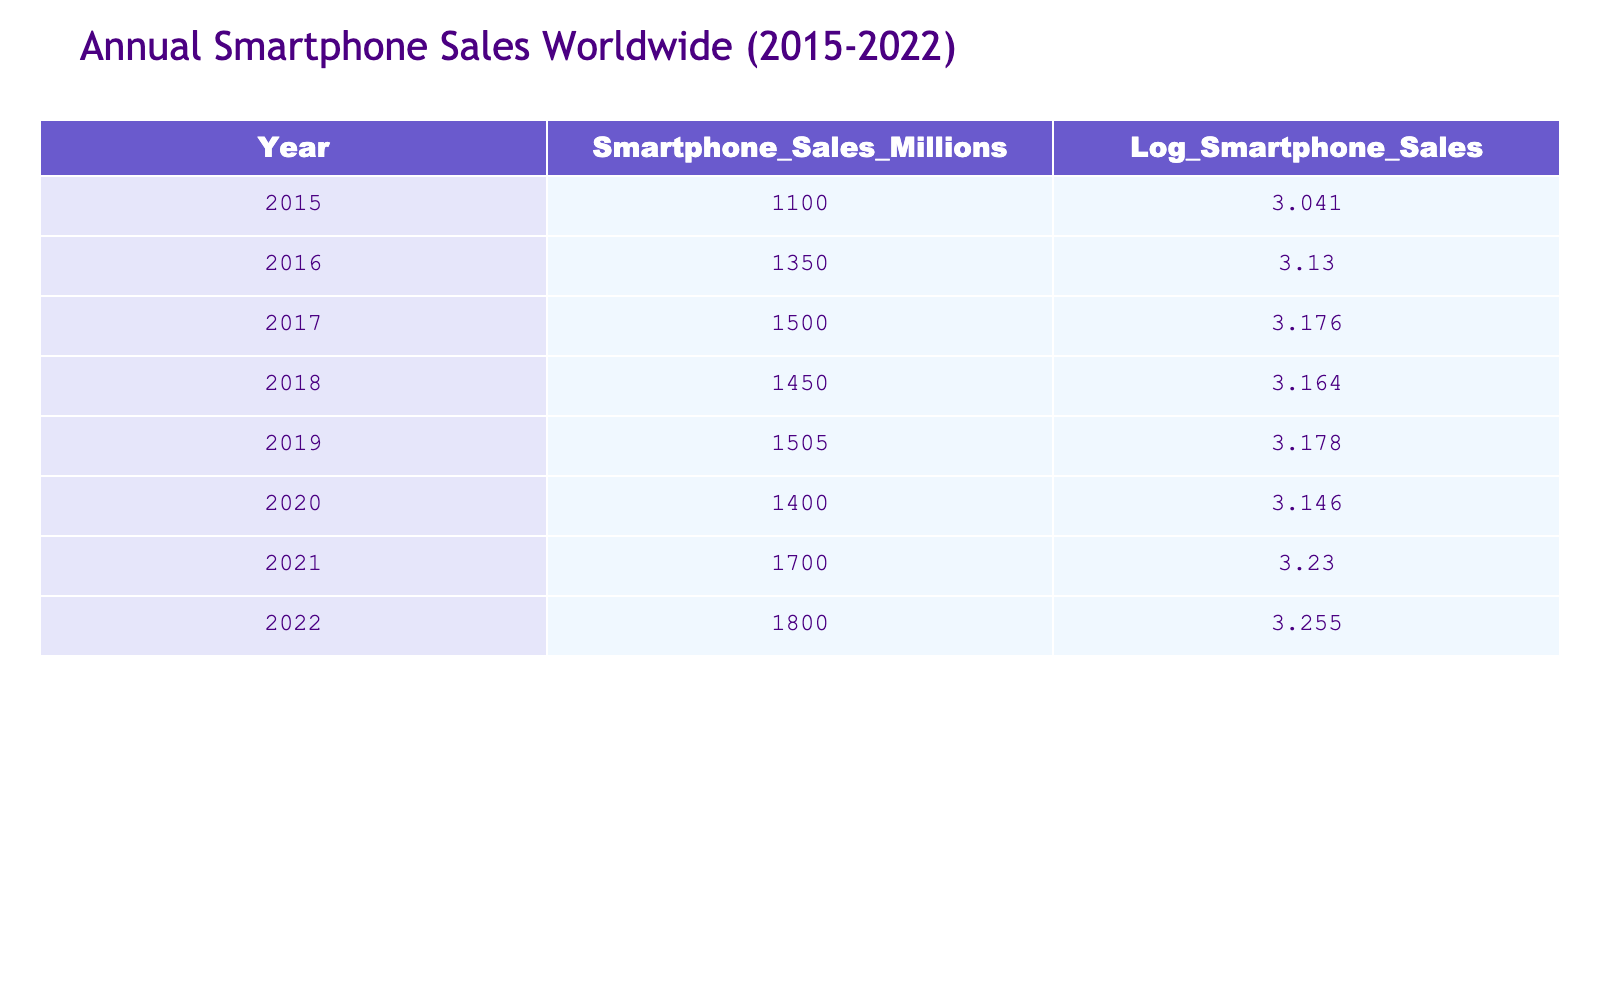What was the smartphone sales figure in 2020? The smartphone sales in 2020 are directly listed in the table under the corresponding year. The value for 2020 is 1400 million.
Answer: 1400 million Which year had the highest smartphone sales? By examining the smartphone sales values, 2022 has the highest figure at 1800 million, which is greater than all the other years listed.
Answer: 2022 What is the difference in smartphone sales between 2015 and 2022? We need to subtract the sales of 2015 from the sales of 2022. The sales in 2022 are 1800 million and in 2015 are 1100 million. The difference is 1800 - 1100 = 700 million.
Answer: 700 million Is it true that smartphone sales decreased from 2017 to 2018? To determine this, we compare the sales figures for 2017 (1500 million) and 2018 (1450 million). Since 1450 million is less than 1500 million, the statement is true.
Answer: Yes What was the average smartphone sales from 2015 to 2022? To find the average, add the smartphone sales of all years: (1100 + 1350 + 1500 + 1450 + 1505 + 1400 + 1700 + 1800) = 11505 million. There are 8 years, so divide the total by 8. The average is 11505 / 8 = 1438.125 million.
Answer: 1438.125 million What was the logarithm of smartphone sales for the year with the lowest sales? The year with the lowest sales recorded is 2015, which has a logarithmic value of 3.041 as shown in the table.
Answer: 3.041 In which years was smartphone sales greater than 1500 million? We look for years where the sales figure exceeds 1500 million. The years that meet this criterion are 2017 (1500 million), 2019 (1505 million), 2021 (1700 million), and 2022 (1800 million).
Answer: 2019, 2021, 2022 What is the total smartphone sales from 2016 to 2022? To calculate the total from 2016 to 2022, we sum the sales figures of those years: 1350 + 1500 + 1450 + 1505 + 1400 + 1700 + 1800 = 10305 million.
Answer: 10305 million Was the growth in smartphone sales from 2021 to 2022 larger than the growth from 2019 to 2020? First, we find the increase from 2021 to 2022: (1800 - 1700) = 100 million. Then, the increase from 2019 to 2020: (1400 - 1505) = -105 million (a decrease). Thus, the increase from 2021 to 2022 is larger than the change from 2019 to 2020.
Answer: Yes 